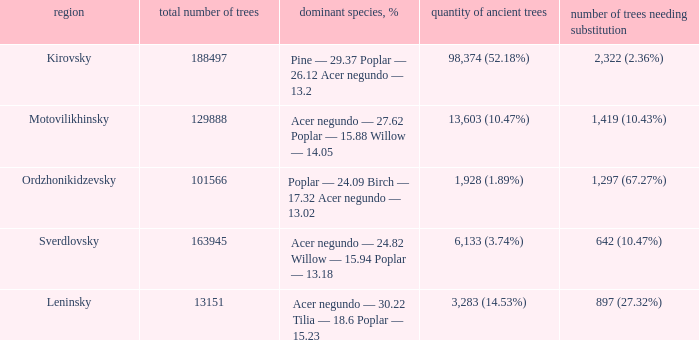What is the district when the total amount of trees is smaller than 150817.6878461314 and amount of old trees is 1,928 (1.89%)? Ordzhonikidzevsky. 